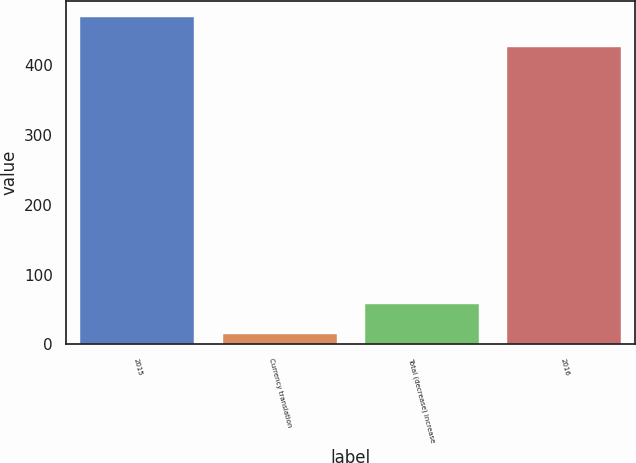<chart> <loc_0><loc_0><loc_500><loc_500><bar_chart><fcel>2015<fcel>Currency translation<fcel>Total (decrease) increase<fcel>2016<nl><fcel>469.14<fcel>14.4<fcel>57.34<fcel>426.2<nl></chart> 